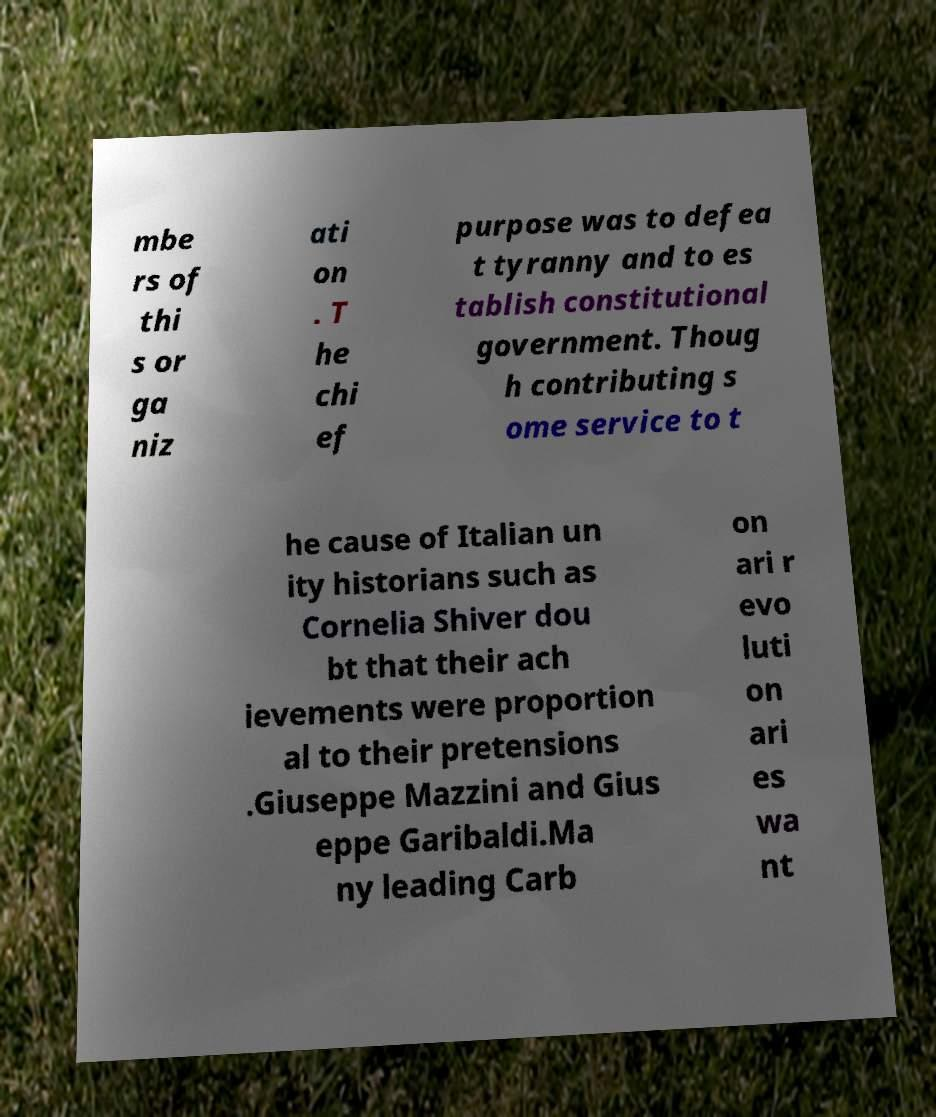Can you accurately transcribe the text from the provided image for me? mbe rs of thi s or ga niz ati on . T he chi ef purpose was to defea t tyranny and to es tablish constitutional government. Thoug h contributing s ome service to t he cause of Italian un ity historians such as Cornelia Shiver dou bt that their ach ievements were proportion al to their pretensions .Giuseppe Mazzini and Gius eppe Garibaldi.Ma ny leading Carb on ari r evo luti on ari es wa nt 